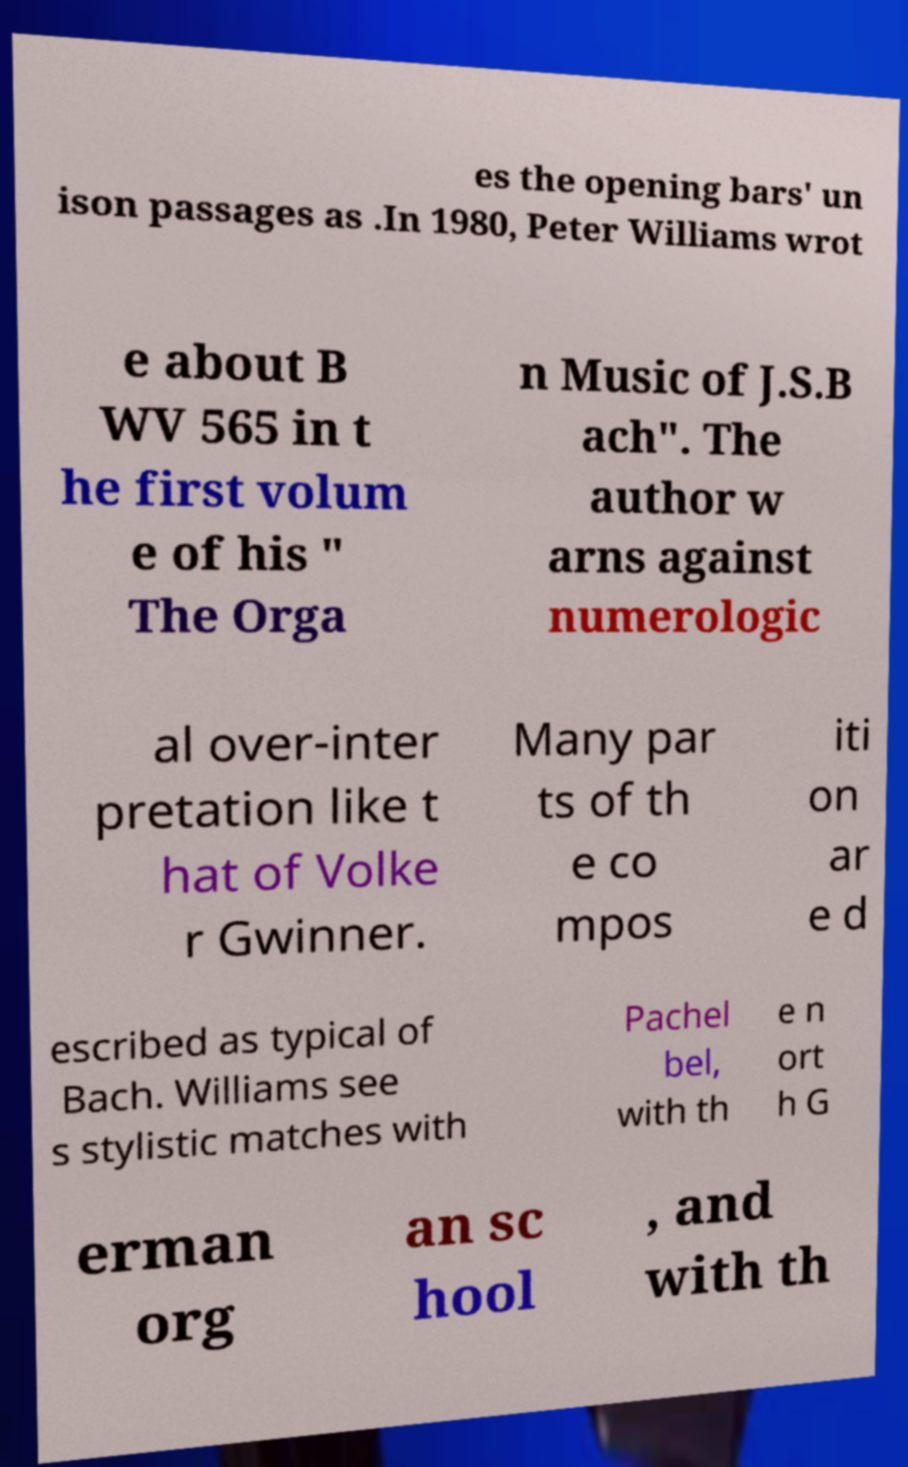There's text embedded in this image that I need extracted. Can you transcribe it verbatim? es the opening bars' un ison passages as .In 1980, Peter Williams wrot e about B WV 565 in t he first volum e of his " The Orga n Music of J.S.B ach". The author w arns against numerologic al over-inter pretation like t hat of Volke r Gwinner. Many par ts of th e co mpos iti on ar e d escribed as typical of Bach. Williams see s stylistic matches with Pachel bel, with th e n ort h G erman org an sc hool , and with th 